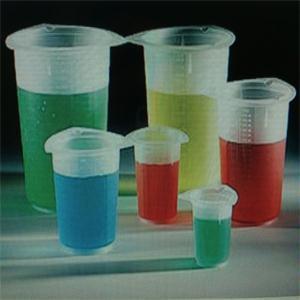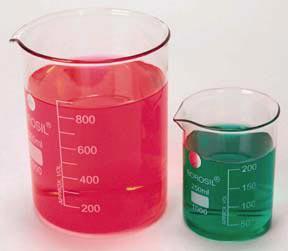The first image is the image on the left, the second image is the image on the right. Given the left and right images, does the statement "One image shows beakers filled with at least three different colors of liquid." hold true? Answer yes or no. Yes. The first image is the image on the left, the second image is the image on the right. For the images shown, is this caption "In one image, there is one beaker with a green liquid and one beaker with a red liquid" true? Answer yes or no. Yes. 